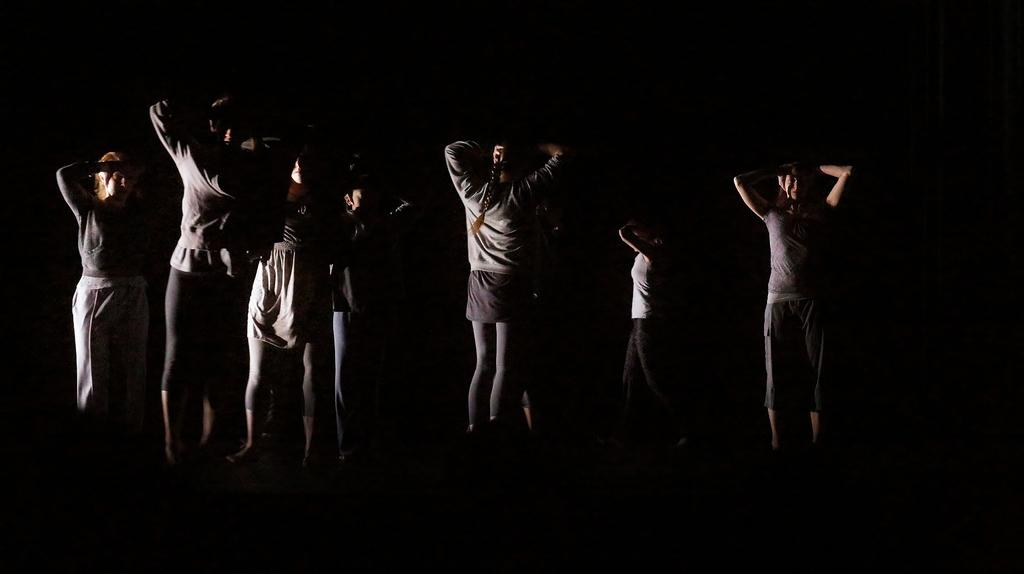What is happening in the image? There is a group of people in the image, and they are standing and holding their hands upwards. What can be observed about the background of the image? The background of the image is dark. What type of star can be seen in the image? There is no star present in the image; it features a group of people standing and holding their hands upwards against a dark background. What creature is interacting with the people in the image? There is no creature present in the image; it only features a group of people standing and holding their hands upwards against a dark background. 